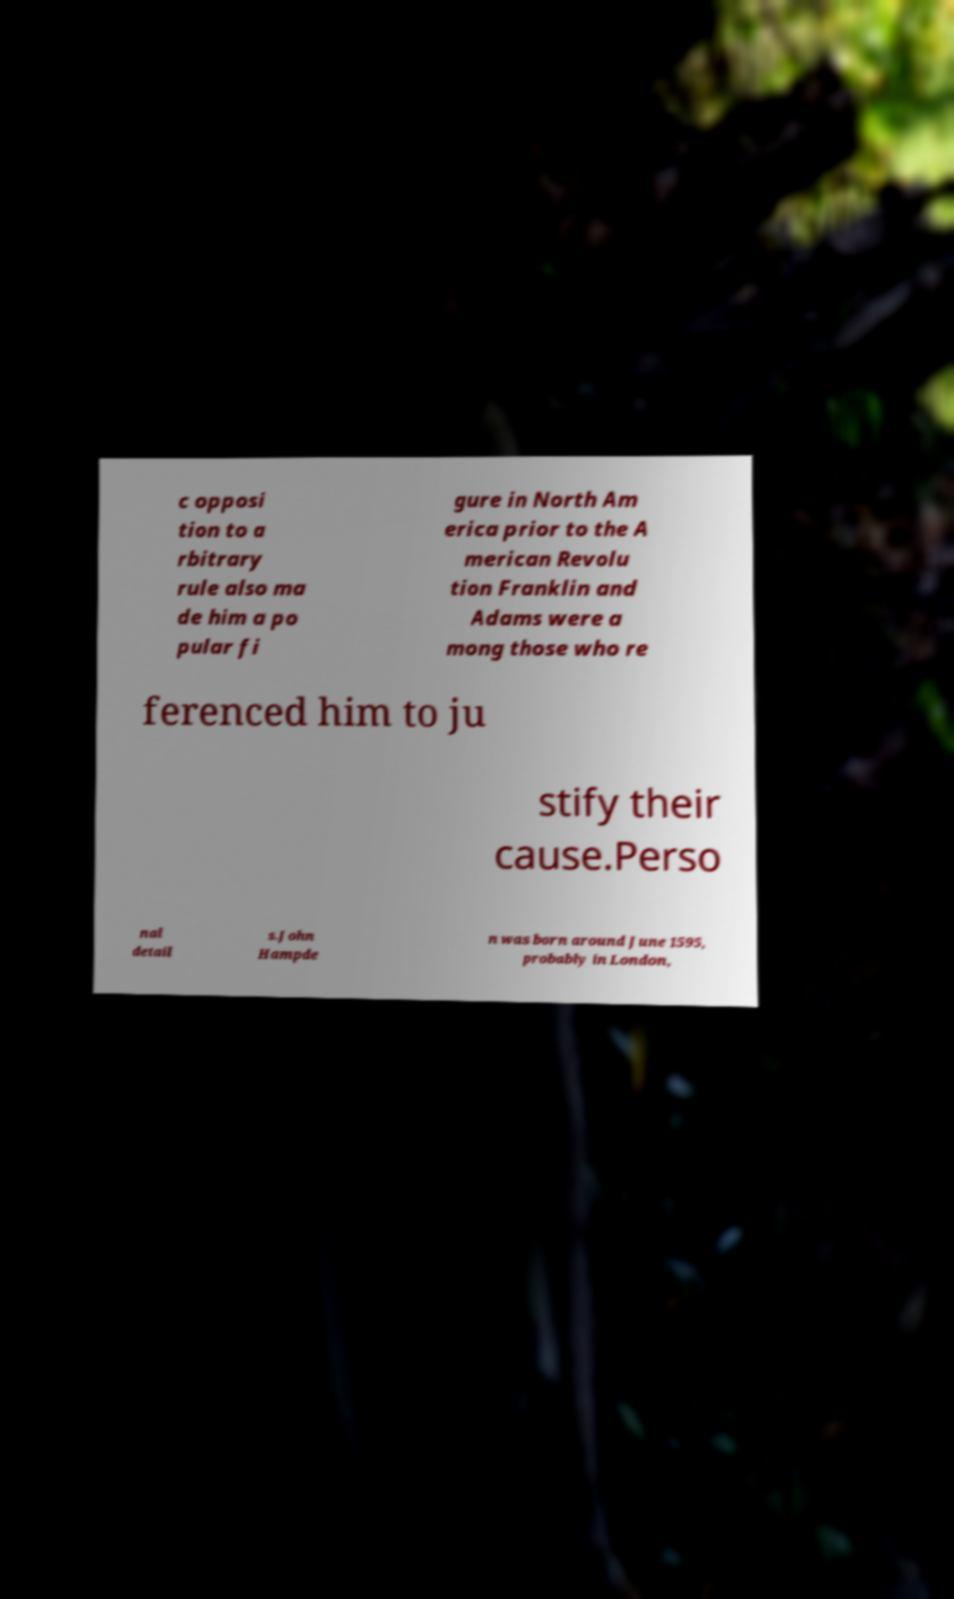Can you accurately transcribe the text from the provided image for me? c opposi tion to a rbitrary rule also ma de him a po pular fi gure in North Am erica prior to the A merican Revolu tion Franklin and Adams were a mong those who re ferenced him to ju stify their cause.Perso nal detail s.John Hampde n was born around June 1595, probably in London, 